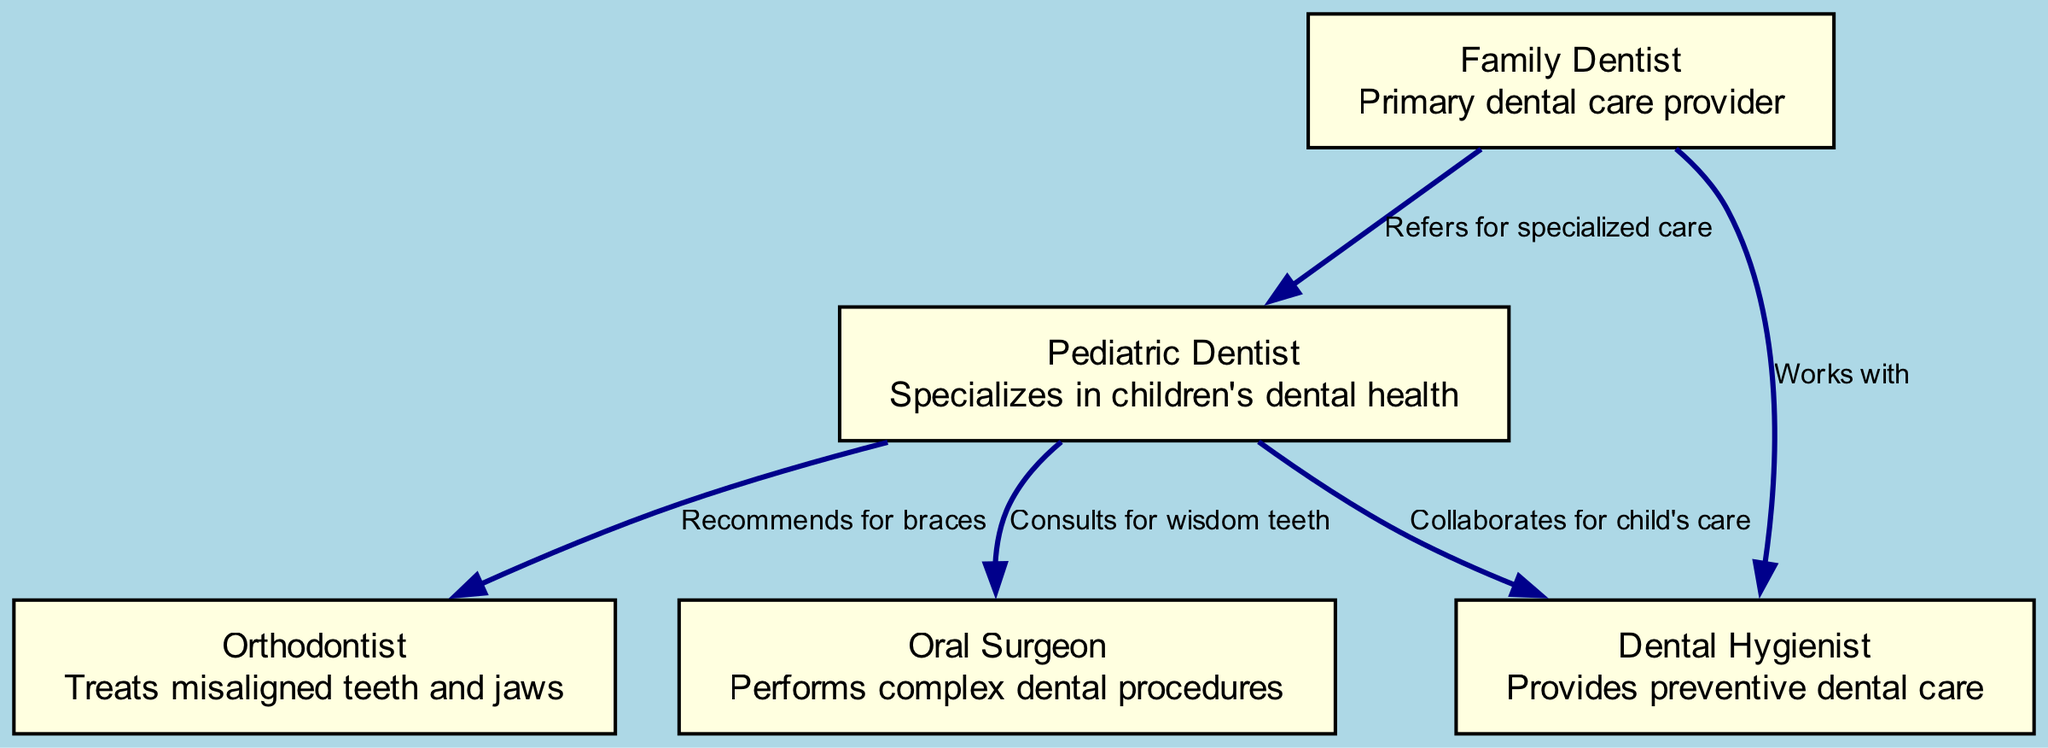What's the total number of nodes in the diagram? The diagram contains five different nodes, each representing a different dental professional involved in a child's dental care.
Answer: 5 Which professional specializes in children's dental health? Looking at the description of the nodes, the Pediatric Dentist is specifically labeled as a specialist in children's dental health.
Answer: Pediatric Dentist Who refers patients for specialized care? The Family Dentist is the node that is designated as referring patients, as indicated by the edge connecting it to the Pediatric Dentist, stating "Refers for specialized care."
Answer: Family Dentist What does the Pediatric Dentist recommend for braces? The edge leading from the Pediatric Dentist to the Orthodontist states that they "Recommends for braces," indicating their role in suggesting treatment for misaligned teeth.
Answer: Orthodontist How many collaborative relationships does the Dental Hygienist have? The Dental Hygienist has two collaborative relationships: one with the Family Dentist and another with the Pediatric Dentist, as shown by the edges indicating collaboration for care.
Answer: 2 What type of professional performs complex dental procedures? The description of the Oral Surgeon specifically states that they perform complex dental procedures, which clearly indicates their role within the network.
Answer: Oral Surgeon Which professional collaborates with the Family Dentist? The Dental Hygienist works with the Family Dentist, as seen in the edge linking the two nodes, showing their cooperative relationship in dental care.
Answer: Dental Hygienist From which dental professional does the Pediatric Dentist consult for wisdom teeth? From the diagram, the connection labeled "Consults for wisdom teeth" shows that the Pediatric Dentist consults the Oral Surgeon for matters related to wisdom teeth.
Answer: Oral Surgeon What is the primary role of the Family Dentist? The Family Dentist is described as the primary dental care provider in the diagram, indicating their fundamental role in a child's dental health management.
Answer: Primary dental care provider 